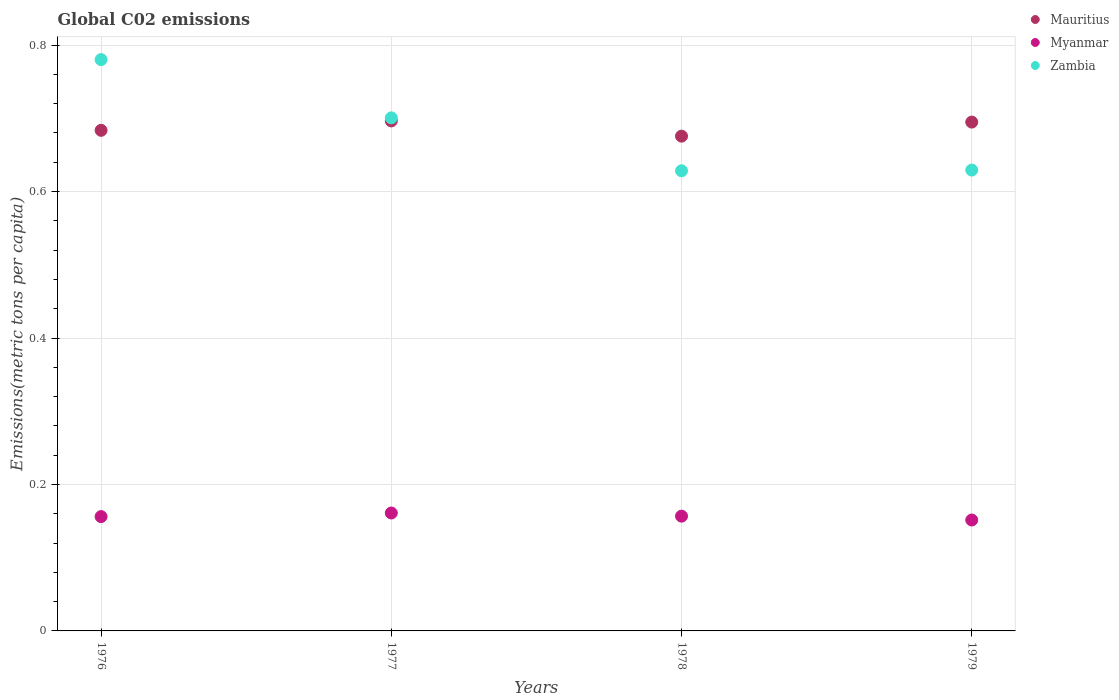Is the number of dotlines equal to the number of legend labels?
Your response must be concise. Yes. What is the amount of CO2 emitted in in Myanmar in 1976?
Provide a succinct answer. 0.16. Across all years, what is the maximum amount of CO2 emitted in in Zambia?
Make the answer very short. 0.78. Across all years, what is the minimum amount of CO2 emitted in in Mauritius?
Make the answer very short. 0.68. In which year was the amount of CO2 emitted in in Myanmar maximum?
Your response must be concise. 1977. In which year was the amount of CO2 emitted in in Zambia minimum?
Make the answer very short. 1978. What is the total amount of CO2 emitted in in Mauritius in the graph?
Ensure brevity in your answer.  2.75. What is the difference between the amount of CO2 emitted in in Myanmar in 1976 and that in 1977?
Offer a very short reply. -0. What is the difference between the amount of CO2 emitted in in Myanmar in 1978 and the amount of CO2 emitted in in Mauritius in 1976?
Your answer should be compact. -0.53. What is the average amount of CO2 emitted in in Myanmar per year?
Provide a short and direct response. 0.16. In the year 1978, what is the difference between the amount of CO2 emitted in in Mauritius and amount of CO2 emitted in in Myanmar?
Offer a very short reply. 0.52. In how many years, is the amount of CO2 emitted in in Mauritius greater than 0.28 metric tons per capita?
Your response must be concise. 4. What is the ratio of the amount of CO2 emitted in in Myanmar in 1978 to that in 1979?
Offer a very short reply. 1.03. Is the amount of CO2 emitted in in Zambia in 1978 less than that in 1979?
Provide a short and direct response. Yes. What is the difference between the highest and the second highest amount of CO2 emitted in in Mauritius?
Make the answer very short. 0. What is the difference between the highest and the lowest amount of CO2 emitted in in Mauritius?
Make the answer very short. 0.02. Is the sum of the amount of CO2 emitted in in Myanmar in 1977 and 1978 greater than the maximum amount of CO2 emitted in in Mauritius across all years?
Offer a terse response. No. Does the amount of CO2 emitted in in Myanmar monotonically increase over the years?
Your response must be concise. No. Is the amount of CO2 emitted in in Myanmar strictly greater than the amount of CO2 emitted in in Mauritius over the years?
Make the answer very short. No. Is the amount of CO2 emitted in in Mauritius strictly less than the amount of CO2 emitted in in Myanmar over the years?
Provide a succinct answer. No. Are the values on the major ticks of Y-axis written in scientific E-notation?
Provide a succinct answer. No. What is the title of the graph?
Provide a succinct answer. Global C02 emissions. What is the label or title of the X-axis?
Make the answer very short. Years. What is the label or title of the Y-axis?
Provide a short and direct response. Emissions(metric tons per capita). What is the Emissions(metric tons per capita) in Mauritius in 1976?
Your response must be concise. 0.68. What is the Emissions(metric tons per capita) of Myanmar in 1976?
Your answer should be very brief. 0.16. What is the Emissions(metric tons per capita) in Zambia in 1976?
Provide a short and direct response. 0.78. What is the Emissions(metric tons per capita) of Mauritius in 1977?
Offer a very short reply. 0.7. What is the Emissions(metric tons per capita) of Myanmar in 1977?
Give a very brief answer. 0.16. What is the Emissions(metric tons per capita) in Zambia in 1977?
Give a very brief answer. 0.7. What is the Emissions(metric tons per capita) of Mauritius in 1978?
Make the answer very short. 0.68. What is the Emissions(metric tons per capita) of Myanmar in 1978?
Provide a succinct answer. 0.16. What is the Emissions(metric tons per capita) in Zambia in 1978?
Ensure brevity in your answer.  0.63. What is the Emissions(metric tons per capita) in Mauritius in 1979?
Make the answer very short. 0.69. What is the Emissions(metric tons per capita) in Myanmar in 1979?
Keep it short and to the point. 0.15. What is the Emissions(metric tons per capita) in Zambia in 1979?
Provide a succinct answer. 0.63. Across all years, what is the maximum Emissions(metric tons per capita) of Mauritius?
Offer a very short reply. 0.7. Across all years, what is the maximum Emissions(metric tons per capita) in Myanmar?
Ensure brevity in your answer.  0.16. Across all years, what is the maximum Emissions(metric tons per capita) of Zambia?
Make the answer very short. 0.78. Across all years, what is the minimum Emissions(metric tons per capita) in Mauritius?
Give a very brief answer. 0.68. Across all years, what is the minimum Emissions(metric tons per capita) in Myanmar?
Provide a short and direct response. 0.15. Across all years, what is the minimum Emissions(metric tons per capita) of Zambia?
Your response must be concise. 0.63. What is the total Emissions(metric tons per capita) in Mauritius in the graph?
Provide a succinct answer. 2.75. What is the total Emissions(metric tons per capita) in Myanmar in the graph?
Give a very brief answer. 0.63. What is the total Emissions(metric tons per capita) in Zambia in the graph?
Your answer should be very brief. 2.74. What is the difference between the Emissions(metric tons per capita) of Mauritius in 1976 and that in 1977?
Offer a very short reply. -0.01. What is the difference between the Emissions(metric tons per capita) of Myanmar in 1976 and that in 1977?
Offer a very short reply. -0. What is the difference between the Emissions(metric tons per capita) of Zambia in 1976 and that in 1977?
Make the answer very short. 0.08. What is the difference between the Emissions(metric tons per capita) of Mauritius in 1976 and that in 1978?
Provide a succinct answer. 0.01. What is the difference between the Emissions(metric tons per capita) in Myanmar in 1976 and that in 1978?
Make the answer very short. -0. What is the difference between the Emissions(metric tons per capita) in Zambia in 1976 and that in 1978?
Offer a very short reply. 0.15. What is the difference between the Emissions(metric tons per capita) of Mauritius in 1976 and that in 1979?
Provide a succinct answer. -0.01. What is the difference between the Emissions(metric tons per capita) in Myanmar in 1976 and that in 1979?
Offer a very short reply. 0. What is the difference between the Emissions(metric tons per capita) of Zambia in 1976 and that in 1979?
Your answer should be compact. 0.15. What is the difference between the Emissions(metric tons per capita) of Mauritius in 1977 and that in 1978?
Give a very brief answer. 0.02. What is the difference between the Emissions(metric tons per capita) in Myanmar in 1977 and that in 1978?
Your response must be concise. 0. What is the difference between the Emissions(metric tons per capita) in Zambia in 1977 and that in 1978?
Offer a very short reply. 0.07. What is the difference between the Emissions(metric tons per capita) in Mauritius in 1977 and that in 1979?
Ensure brevity in your answer.  0. What is the difference between the Emissions(metric tons per capita) in Myanmar in 1977 and that in 1979?
Provide a succinct answer. 0.01. What is the difference between the Emissions(metric tons per capita) in Zambia in 1977 and that in 1979?
Give a very brief answer. 0.07. What is the difference between the Emissions(metric tons per capita) of Mauritius in 1978 and that in 1979?
Offer a very short reply. -0.02. What is the difference between the Emissions(metric tons per capita) in Myanmar in 1978 and that in 1979?
Your answer should be very brief. 0.01. What is the difference between the Emissions(metric tons per capita) in Zambia in 1978 and that in 1979?
Give a very brief answer. -0. What is the difference between the Emissions(metric tons per capita) in Mauritius in 1976 and the Emissions(metric tons per capita) in Myanmar in 1977?
Ensure brevity in your answer.  0.52. What is the difference between the Emissions(metric tons per capita) of Mauritius in 1976 and the Emissions(metric tons per capita) of Zambia in 1977?
Offer a terse response. -0.02. What is the difference between the Emissions(metric tons per capita) of Myanmar in 1976 and the Emissions(metric tons per capita) of Zambia in 1977?
Offer a terse response. -0.54. What is the difference between the Emissions(metric tons per capita) in Mauritius in 1976 and the Emissions(metric tons per capita) in Myanmar in 1978?
Your response must be concise. 0.53. What is the difference between the Emissions(metric tons per capita) of Mauritius in 1976 and the Emissions(metric tons per capita) of Zambia in 1978?
Give a very brief answer. 0.06. What is the difference between the Emissions(metric tons per capita) of Myanmar in 1976 and the Emissions(metric tons per capita) of Zambia in 1978?
Your answer should be very brief. -0.47. What is the difference between the Emissions(metric tons per capita) of Mauritius in 1976 and the Emissions(metric tons per capita) of Myanmar in 1979?
Provide a succinct answer. 0.53. What is the difference between the Emissions(metric tons per capita) of Mauritius in 1976 and the Emissions(metric tons per capita) of Zambia in 1979?
Keep it short and to the point. 0.05. What is the difference between the Emissions(metric tons per capita) of Myanmar in 1976 and the Emissions(metric tons per capita) of Zambia in 1979?
Keep it short and to the point. -0.47. What is the difference between the Emissions(metric tons per capita) in Mauritius in 1977 and the Emissions(metric tons per capita) in Myanmar in 1978?
Give a very brief answer. 0.54. What is the difference between the Emissions(metric tons per capita) of Mauritius in 1977 and the Emissions(metric tons per capita) of Zambia in 1978?
Your answer should be very brief. 0.07. What is the difference between the Emissions(metric tons per capita) in Myanmar in 1977 and the Emissions(metric tons per capita) in Zambia in 1978?
Ensure brevity in your answer.  -0.47. What is the difference between the Emissions(metric tons per capita) in Mauritius in 1977 and the Emissions(metric tons per capita) in Myanmar in 1979?
Provide a succinct answer. 0.55. What is the difference between the Emissions(metric tons per capita) in Mauritius in 1977 and the Emissions(metric tons per capita) in Zambia in 1979?
Make the answer very short. 0.07. What is the difference between the Emissions(metric tons per capita) in Myanmar in 1977 and the Emissions(metric tons per capita) in Zambia in 1979?
Your answer should be compact. -0.47. What is the difference between the Emissions(metric tons per capita) of Mauritius in 1978 and the Emissions(metric tons per capita) of Myanmar in 1979?
Make the answer very short. 0.52. What is the difference between the Emissions(metric tons per capita) of Mauritius in 1978 and the Emissions(metric tons per capita) of Zambia in 1979?
Provide a short and direct response. 0.05. What is the difference between the Emissions(metric tons per capita) of Myanmar in 1978 and the Emissions(metric tons per capita) of Zambia in 1979?
Make the answer very short. -0.47. What is the average Emissions(metric tons per capita) of Mauritius per year?
Your answer should be compact. 0.69. What is the average Emissions(metric tons per capita) in Myanmar per year?
Your answer should be compact. 0.16. What is the average Emissions(metric tons per capita) in Zambia per year?
Ensure brevity in your answer.  0.68. In the year 1976, what is the difference between the Emissions(metric tons per capita) of Mauritius and Emissions(metric tons per capita) of Myanmar?
Provide a succinct answer. 0.53. In the year 1976, what is the difference between the Emissions(metric tons per capita) of Mauritius and Emissions(metric tons per capita) of Zambia?
Provide a succinct answer. -0.1. In the year 1976, what is the difference between the Emissions(metric tons per capita) in Myanmar and Emissions(metric tons per capita) in Zambia?
Your answer should be compact. -0.62. In the year 1977, what is the difference between the Emissions(metric tons per capita) in Mauritius and Emissions(metric tons per capita) in Myanmar?
Your answer should be compact. 0.54. In the year 1977, what is the difference between the Emissions(metric tons per capita) of Mauritius and Emissions(metric tons per capita) of Zambia?
Provide a short and direct response. -0. In the year 1977, what is the difference between the Emissions(metric tons per capita) of Myanmar and Emissions(metric tons per capita) of Zambia?
Your answer should be very brief. -0.54. In the year 1978, what is the difference between the Emissions(metric tons per capita) of Mauritius and Emissions(metric tons per capita) of Myanmar?
Provide a short and direct response. 0.52. In the year 1978, what is the difference between the Emissions(metric tons per capita) of Mauritius and Emissions(metric tons per capita) of Zambia?
Offer a very short reply. 0.05. In the year 1978, what is the difference between the Emissions(metric tons per capita) in Myanmar and Emissions(metric tons per capita) in Zambia?
Give a very brief answer. -0.47. In the year 1979, what is the difference between the Emissions(metric tons per capita) in Mauritius and Emissions(metric tons per capita) in Myanmar?
Ensure brevity in your answer.  0.54. In the year 1979, what is the difference between the Emissions(metric tons per capita) of Mauritius and Emissions(metric tons per capita) of Zambia?
Ensure brevity in your answer.  0.07. In the year 1979, what is the difference between the Emissions(metric tons per capita) of Myanmar and Emissions(metric tons per capita) of Zambia?
Keep it short and to the point. -0.48. What is the ratio of the Emissions(metric tons per capita) in Mauritius in 1976 to that in 1977?
Your answer should be compact. 0.98. What is the ratio of the Emissions(metric tons per capita) in Myanmar in 1976 to that in 1977?
Offer a terse response. 0.97. What is the ratio of the Emissions(metric tons per capita) in Zambia in 1976 to that in 1977?
Your response must be concise. 1.11. What is the ratio of the Emissions(metric tons per capita) of Mauritius in 1976 to that in 1978?
Provide a short and direct response. 1.01. What is the ratio of the Emissions(metric tons per capita) of Myanmar in 1976 to that in 1978?
Make the answer very short. 1. What is the ratio of the Emissions(metric tons per capita) of Zambia in 1976 to that in 1978?
Provide a succinct answer. 1.24. What is the ratio of the Emissions(metric tons per capita) in Mauritius in 1976 to that in 1979?
Give a very brief answer. 0.98. What is the ratio of the Emissions(metric tons per capita) of Myanmar in 1976 to that in 1979?
Offer a terse response. 1.03. What is the ratio of the Emissions(metric tons per capita) of Zambia in 1976 to that in 1979?
Give a very brief answer. 1.24. What is the ratio of the Emissions(metric tons per capita) in Mauritius in 1977 to that in 1978?
Your response must be concise. 1.03. What is the ratio of the Emissions(metric tons per capita) of Myanmar in 1977 to that in 1978?
Provide a succinct answer. 1.03. What is the ratio of the Emissions(metric tons per capita) of Zambia in 1977 to that in 1978?
Give a very brief answer. 1.12. What is the ratio of the Emissions(metric tons per capita) in Mauritius in 1977 to that in 1979?
Give a very brief answer. 1. What is the ratio of the Emissions(metric tons per capita) in Myanmar in 1977 to that in 1979?
Your answer should be compact. 1.06. What is the ratio of the Emissions(metric tons per capita) in Zambia in 1977 to that in 1979?
Your answer should be very brief. 1.11. What is the ratio of the Emissions(metric tons per capita) of Mauritius in 1978 to that in 1979?
Provide a short and direct response. 0.97. What is the ratio of the Emissions(metric tons per capita) in Myanmar in 1978 to that in 1979?
Your response must be concise. 1.03. What is the ratio of the Emissions(metric tons per capita) of Zambia in 1978 to that in 1979?
Provide a succinct answer. 1. What is the difference between the highest and the second highest Emissions(metric tons per capita) of Mauritius?
Your response must be concise. 0. What is the difference between the highest and the second highest Emissions(metric tons per capita) of Myanmar?
Offer a very short reply. 0. What is the difference between the highest and the second highest Emissions(metric tons per capita) in Zambia?
Provide a succinct answer. 0.08. What is the difference between the highest and the lowest Emissions(metric tons per capita) of Mauritius?
Your answer should be very brief. 0.02. What is the difference between the highest and the lowest Emissions(metric tons per capita) in Myanmar?
Give a very brief answer. 0.01. What is the difference between the highest and the lowest Emissions(metric tons per capita) of Zambia?
Your response must be concise. 0.15. 